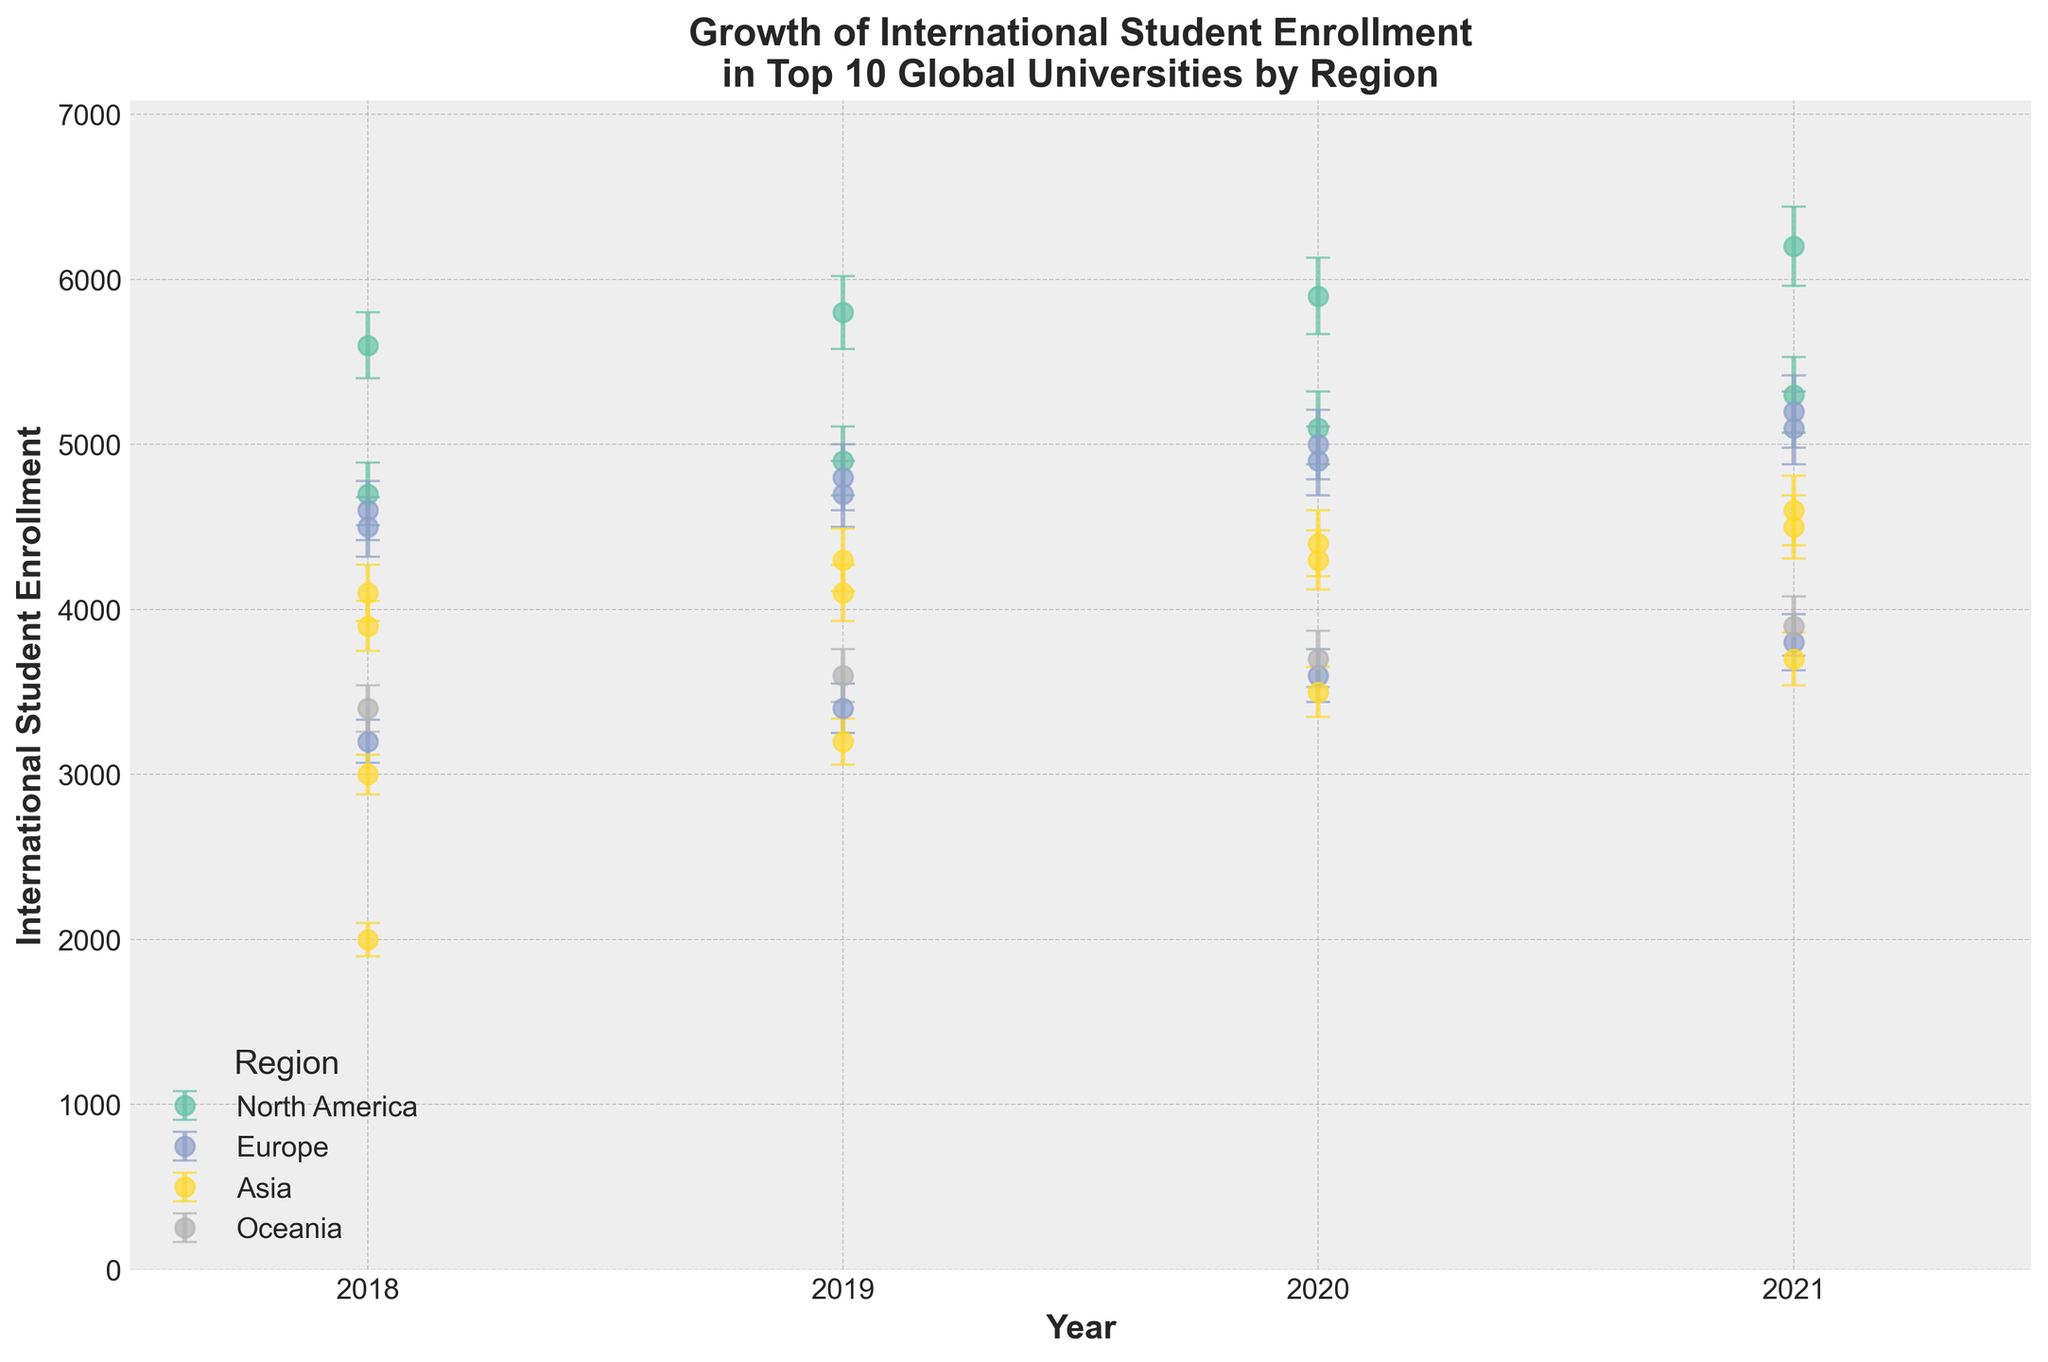Which region has the highest international student enrollment in 2021? Look at the data points for 2021 and compare the enrollment values for each region. North America has the highest value with Harvard University recording 6200 enrollments.
Answer: North America What is the overall trend of international student enrollment at European universities from 2018 to 2021? Observe the data points for European universities (University of Oxford, ETH Zurich, Imperial College London) from 2018 to 2021. All show an overall increasing trend in enrollments.
Answer: Increasing trend How does the enrollment trend for the University of Tokyo compare to that of Peking University? Look at the data points for both universities. Both universities show an overall increasing trend from 2018 to 2021, with similar growth patterns.
Answer: Similar increasing trend Which university and year have the minimum enrollment value in the dataset? Find the smallest data point in the figure. มหาวทิยาลัยบูรพา in 2018 has the lowest enrollment with 2000 students.
Answer: มหาวทิยาลัยบูรพา, 2018 Compare the error margins for the University of Melbourne between 2018 and 2021. Do they increase, decrease, or stay the same? Look at the error bars for the University of Melbourne from 2018 to 2021. The error margins increase from 140 in 2018 to 180 in 2021.
Answer: Increase What’s the total increase in enrollment for Harvard University from 2018 to 2021? Subtract the 2018 enrollment value from the 2021 value for Harvard University: 6200 - 5600 = 600.
Answer: 600 Which university in Asia shows the greatest increase in international student enrollment from 2018 to 2021? Compare the increase for universities in Asia (University of Tokyo, Peking University, National University of Singapore). The University of Tokyo shows the greatest increase: 4600 - 4100 = 500.
Answer: University of Tokyo How does the fluctuation in enrollment numbers for the University of Toronto compare to that of ETH Zurich? Compare the size of the error bars for the two universities. The University of Toronto has consistently larger error bars indicating more fluctuation compared to ETH Zurich.
Answer: University of Toronto has more fluctuation Between 2018 and 2021, which region had the least variation in error margins across universities? Compare the error bars for universities within each region. Europe's universities display smaller increases in error margins compared to other regions.
Answer: Europe What is the average enrollment for Imperial College London between 2018 and 2021? Add the enrollment values for Imperial College London from each year and divide by the number of years: (4600 + 4800 + 5000 + 5200) / 4 = 4900.
Answer: 4900 